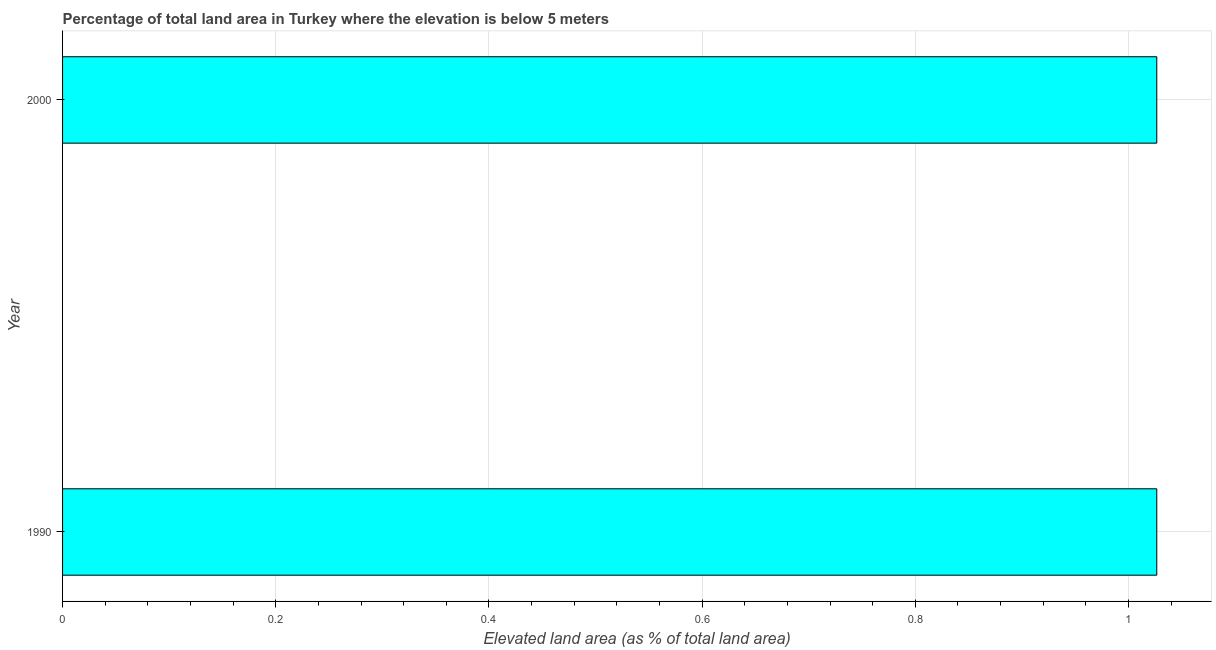Does the graph contain any zero values?
Give a very brief answer. No. What is the title of the graph?
Your answer should be very brief. Percentage of total land area in Turkey where the elevation is below 5 meters. What is the label or title of the X-axis?
Keep it short and to the point. Elevated land area (as % of total land area). What is the total elevated land area in 2000?
Provide a succinct answer. 1.03. Across all years, what is the maximum total elevated land area?
Give a very brief answer. 1.03. Across all years, what is the minimum total elevated land area?
Give a very brief answer. 1.03. In which year was the total elevated land area maximum?
Offer a very short reply. 1990. What is the sum of the total elevated land area?
Make the answer very short. 2.05. What is the average total elevated land area per year?
Make the answer very short. 1.03. What is the median total elevated land area?
Your answer should be very brief. 1.03. In how many years, is the total elevated land area greater than 0.6 %?
Your answer should be compact. 2. Do a majority of the years between 1990 and 2000 (inclusive) have total elevated land area greater than 0.6 %?
Keep it short and to the point. Yes. What is the ratio of the total elevated land area in 1990 to that in 2000?
Give a very brief answer. 1. Is the total elevated land area in 1990 less than that in 2000?
Your answer should be very brief. No. How many bars are there?
Offer a very short reply. 2. How many years are there in the graph?
Ensure brevity in your answer.  2. What is the difference between two consecutive major ticks on the X-axis?
Ensure brevity in your answer.  0.2. Are the values on the major ticks of X-axis written in scientific E-notation?
Offer a terse response. No. What is the Elevated land area (as % of total land area) of 1990?
Provide a short and direct response. 1.03. What is the Elevated land area (as % of total land area) in 2000?
Provide a succinct answer. 1.03. What is the difference between the Elevated land area (as % of total land area) in 1990 and 2000?
Provide a succinct answer. 0. What is the ratio of the Elevated land area (as % of total land area) in 1990 to that in 2000?
Your response must be concise. 1. 